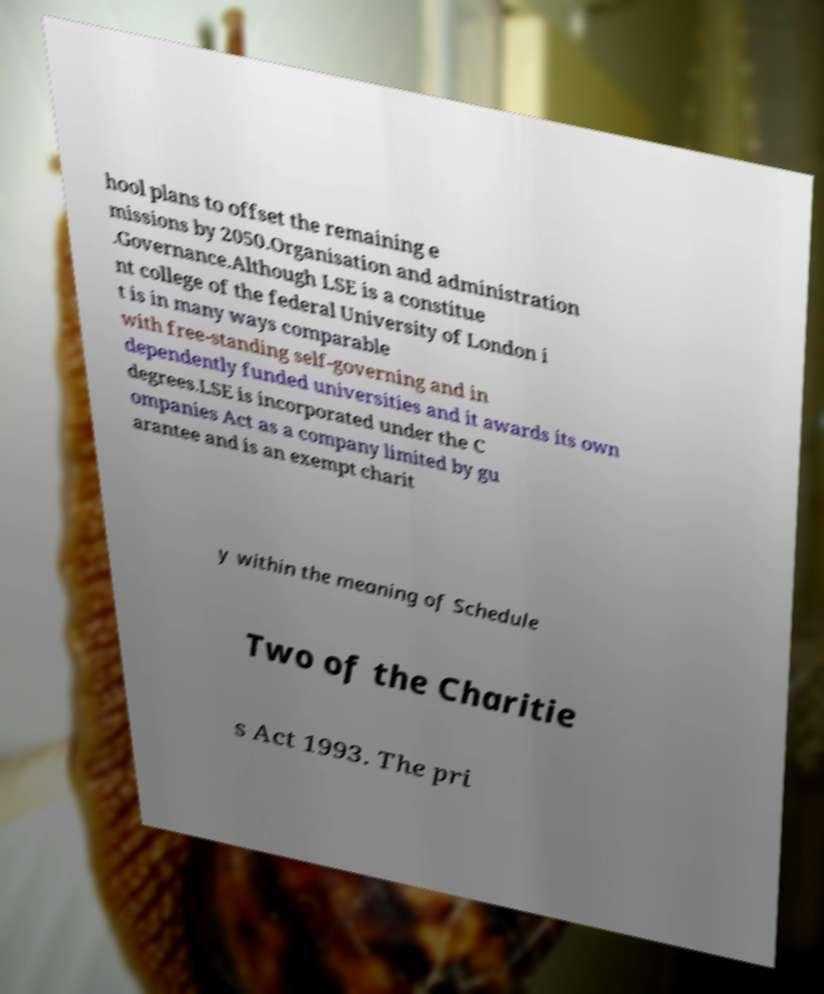I need the written content from this picture converted into text. Can you do that? hool plans to offset the remaining e missions by 2050.Organisation and administration .Governance.Although LSE is a constitue nt college of the federal University of London i t is in many ways comparable with free-standing self-governing and in dependently funded universities and it awards its own degrees.LSE is incorporated under the C ompanies Act as a company limited by gu arantee and is an exempt charit y within the meaning of Schedule Two of the Charitie s Act 1993. The pri 